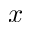<formula> <loc_0><loc_0><loc_500><loc_500>x</formula> 